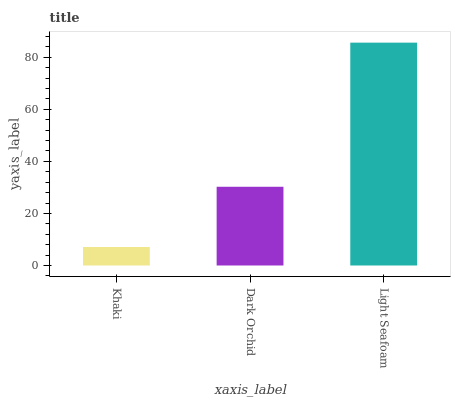Is Khaki the minimum?
Answer yes or no. Yes. Is Light Seafoam the maximum?
Answer yes or no. Yes. Is Dark Orchid the minimum?
Answer yes or no. No. Is Dark Orchid the maximum?
Answer yes or no. No. Is Dark Orchid greater than Khaki?
Answer yes or no. Yes. Is Khaki less than Dark Orchid?
Answer yes or no. Yes. Is Khaki greater than Dark Orchid?
Answer yes or no. No. Is Dark Orchid less than Khaki?
Answer yes or no. No. Is Dark Orchid the high median?
Answer yes or no. Yes. Is Dark Orchid the low median?
Answer yes or no. Yes. Is Light Seafoam the high median?
Answer yes or no. No. Is Khaki the low median?
Answer yes or no. No. 